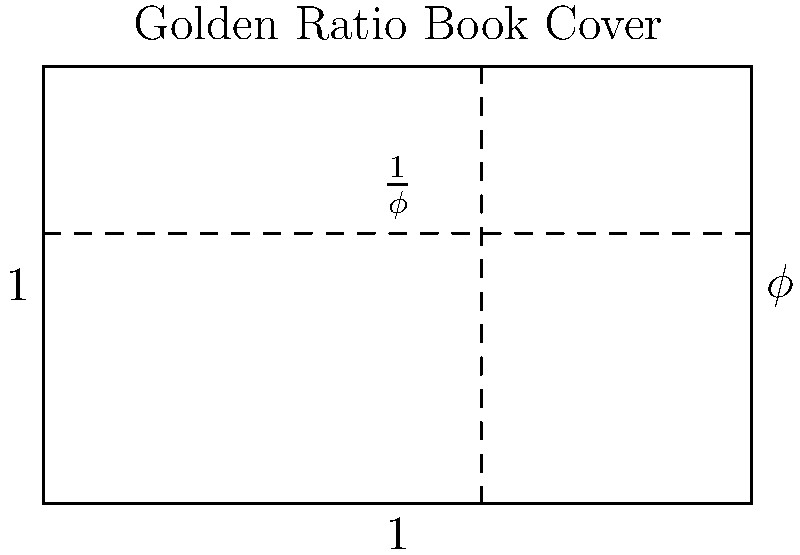In the book cover design shown above, the width-to-height ratio follows the golden ratio ($\phi$). If the height of the cover is 8 inches, what is the width of the cover to the nearest tenth of an inch? To solve this problem, we'll follow these steps:

1. Recall the golden ratio formula: $\phi = \frac{a+b}{a} = \frac{a}{b}$, where $a$ is the longer side and $b$ is the shorter side.

2. In this case, the width is the longer side (a) and the height is the shorter side (b).

3. We know the height is 8 inches, so $b = 8$.

4. The golden ratio $\phi$ is approximately 1.618.

5. Using the formula $\phi = \frac{a}{b}$, we can set up the equation:
   $1.618 = \frac{a}{8}$

6. Solve for $a$ by multiplying both sides by 8:
   $a = 1.618 \times 8 = 12.944$ inches

7. Rounding to the nearest tenth of an inch:
   $12.944$ rounds to $12.9$ inches

Therefore, the width of the book cover is approximately 12.9 inches.
Answer: 12.9 inches 